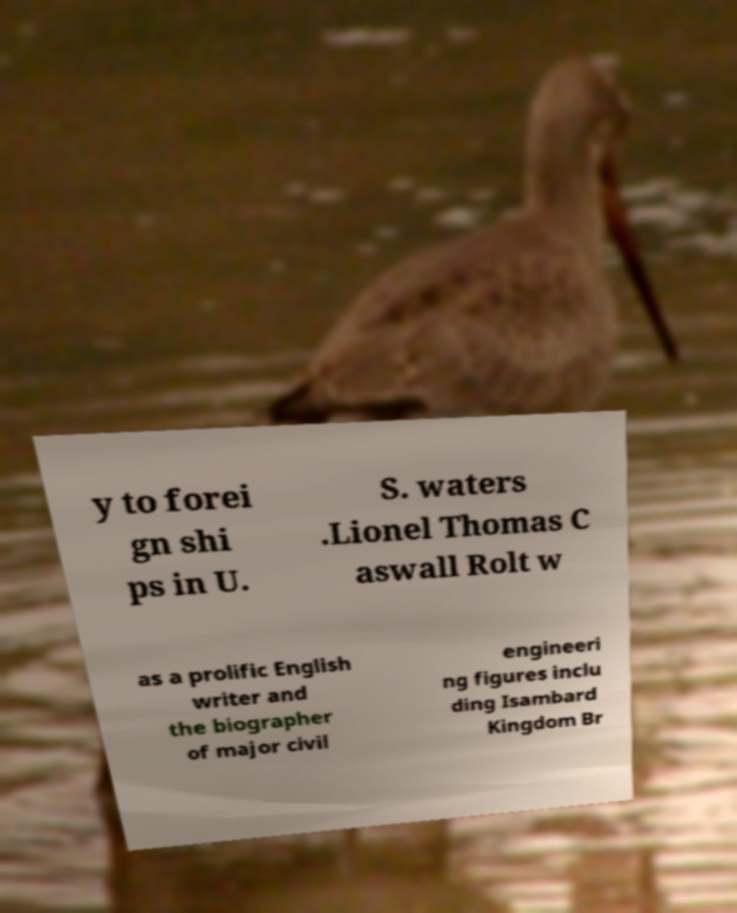Please identify and transcribe the text found in this image. y to forei gn shi ps in U. S. waters .Lionel Thomas C aswall Rolt w as a prolific English writer and the biographer of major civil engineeri ng figures inclu ding Isambard Kingdom Br 